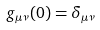Convert formula to latex. <formula><loc_0><loc_0><loc_500><loc_500>g _ { \mu \nu } ( 0 ) = \delta _ { \mu \nu }</formula> 